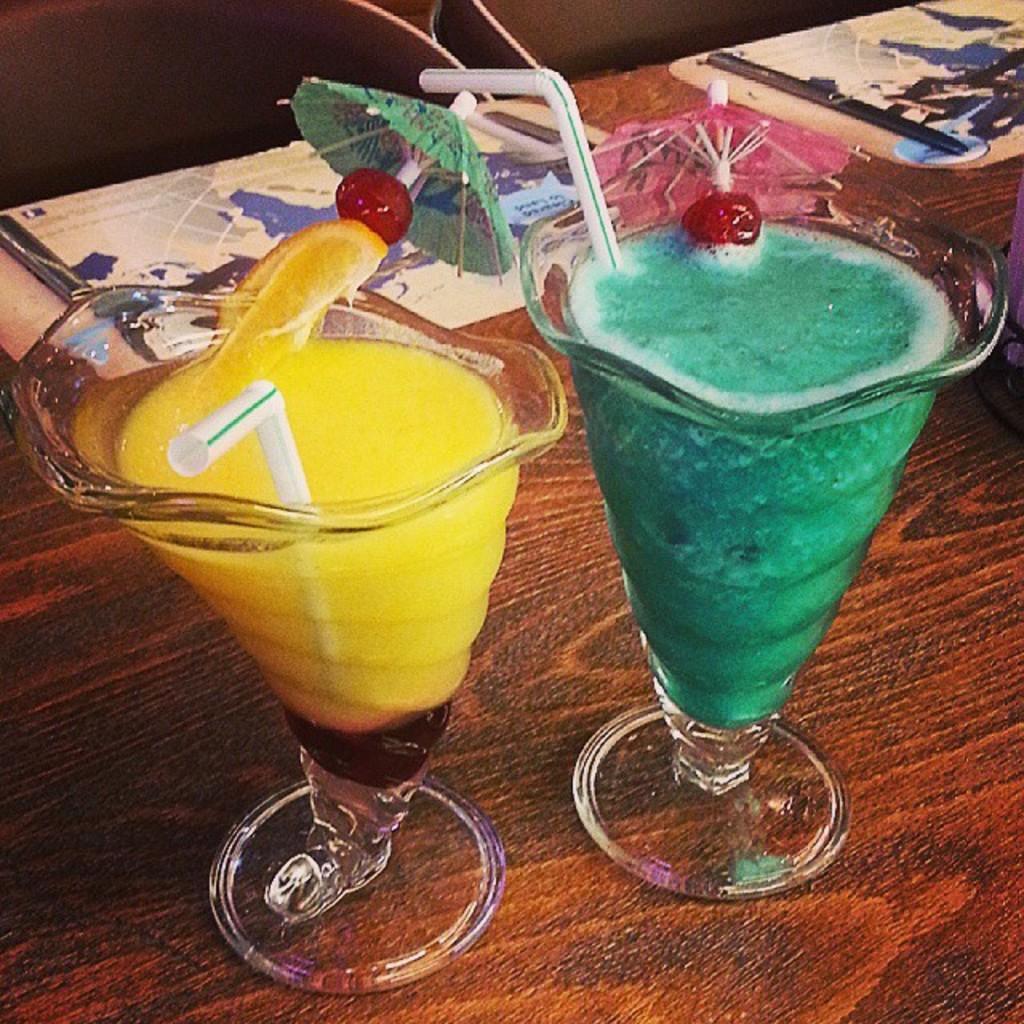How many glasses can be seen in the image? There are two glasses in the image. What is inside the glasses? The glasses contain a drink. What can be used to sip the drink in the glasses? There are white color straws in the glasses. Where are the glasses placed? The glasses are placed on a table. What type of record is playing in the background of the image? There is no record or music player present in the image, so it is not possible to determine what type of record might be playing. 